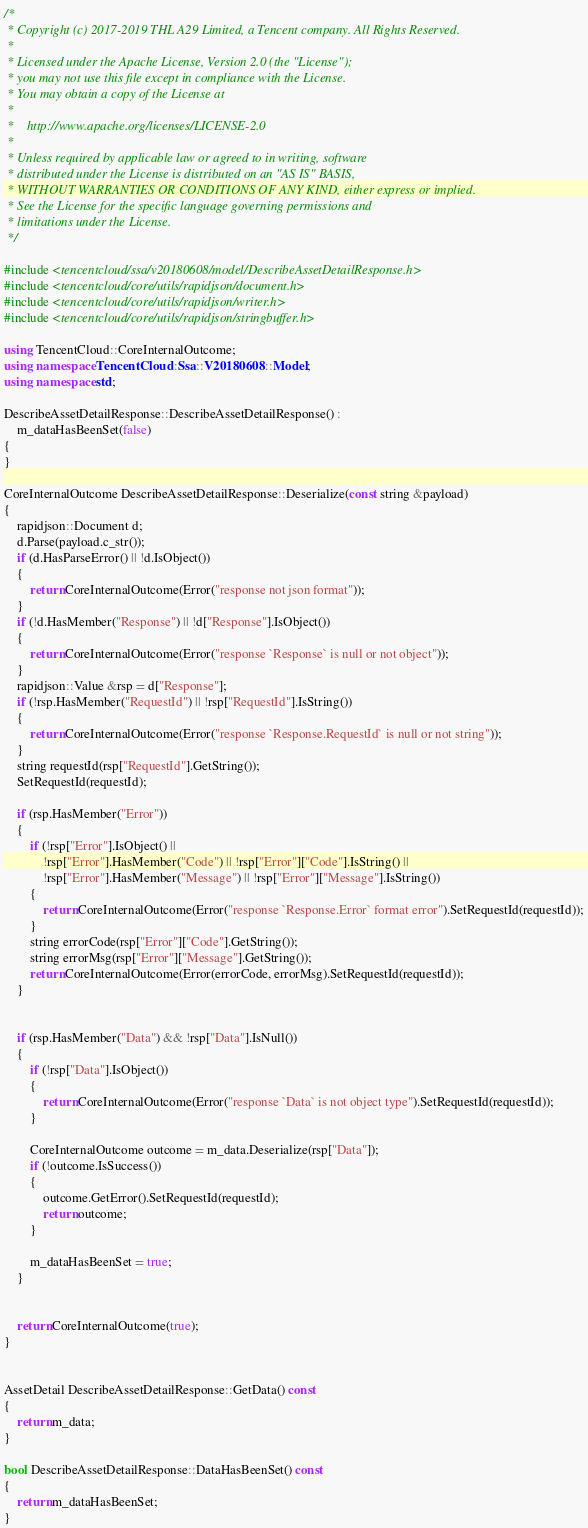Convert code to text. <code><loc_0><loc_0><loc_500><loc_500><_C++_>/*
 * Copyright (c) 2017-2019 THL A29 Limited, a Tencent company. All Rights Reserved.
 *
 * Licensed under the Apache License, Version 2.0 (the "License");
 * you may not use this file except in compliance with the License.
 * You may obtain a copy of the License at
 *
 *    http://www.apache.org/licenses/LICENSE-2.0
 *
 * Unless required by applicable law or agreed to in writing, software
 * distributed under the License is distributed on an "AS IS" BASIS,
 * WITHOUT WARRANTIES OR CONDITIONS OF ANY KIND, either express or implied.
 * See the License for the specific language governing permissions and
 * limitations under the License.
 */

#include <tencentcloud/ssa/v20180608/model/DescribeAssetDetailResponse.h>
#include <tencentcloud/core/utils/rapidjson/document.h>
#include <tencentcloud/core/utils/rapidjson/writer.h>
#include <tencentcloud/core/utils/rapidjson/stringbuffer.h>

using TencentCloud::CoreInternalOutcome;
using namespace TencentCloud::Ssa::V20180608::Model;
using namespace std;

DescribeAssetDetailResponse::DescribeAssetDetailResponse() :
    m_dataHasBeenSet(false)
{
}

CoreInternalOutcome DescribeAssetDetailResponse::Deserialize(const string &payload)
{
    rapidjson::Document d;
    d.Parse(payload.c_str());
    if (d.HasParseError() || !d.IsObject())
    {
        return CoreInternalOutcome(Error("response not json format"));
    }
    if (!d.HasMember("Response") || !d["Response"].IsObject())
    {
        return CoreInternalOutcome(Error("response `Response` is null or not object"));
    }
    rapidjson::Value &rsp = d["Response"];
    if (!rsp.HasMember("RequestId") || !rsp["RequestId"].IsString())
    {
        return CoreInternalOutcome(Error("response `Response.RequestId` is null or not string"));
    }
    string requestId(rsp["RequestId"].GetString());
    SetRequestId(requestId);

    if (rsp.HasMember("Error"))
    {
        if (!rsp["Error"].IsObject() ||
            !rsp["Error"].HasMember("Code") || !rsp["Error"]["Code"].IsString() ||
            !rsp["Error"].HasMember("Message") || !rsp["Error"]["Message"].IsString())
        {
            return CoreInternalOutcome(Error("response `Response.Error` format error").SetRequestId(requestId));
        }
        string errorCode(rsp["Error"]["Code"].GetString());
        string errorMsg(rsp["Error"]["Message"].GetString());
        return CoreInternalOutcome(Error(errorCode, errorMsg).SetRequestId(requestId));
    }


    if (rsp.HasMember("Data") && !rsp["Data"].IsNull())
    {
        if (!rsp["Data"].IsObject())
        {
            return CoreInternalOutcome(Error("response `Data` is not object type").SetRequestId(requestId));
        }

        CoreInternalOutcome outcome = m_data.Deserialize(rsp["Data"]);
        if (!outcome.IsSuccess())
        {
            outcome.GetError().SetRequestId(requestId);
            return outcome;
        }

        m_dataHasBeenSet = true;
    }


    return CoreInternalOutcome(true);
}


AssetDetail DescribeAssetDetailResponse::GetData() const
{
    return m_data;
}

bool DescribeAssetDetailResponse::DataHasBeenSet() const
{
    return m_dataHasBeenSet;
}


</code> 